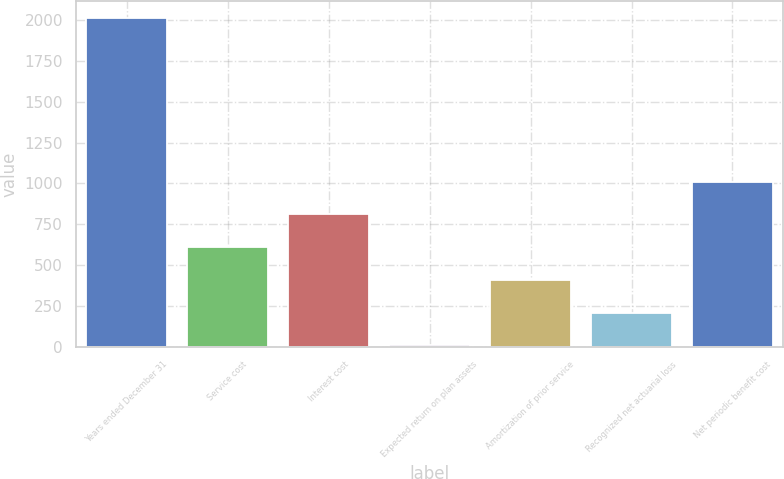<chart> <loc_0><loc_0><loc_500><loc_500><bar_chart><fcel>Years ended December 31<fcel>Service cost<fcel>Interest cost<fcel>Expected return on plan assets<fcel>Amortization of prior service<fcel>Recognized net actuarial loss<fcel>Net periodic benefit cost<nl><fcel>2016<fcel>610.4<fcel>811.2<fcel>8<fcel>409.6<fcel>208.8<fcel>1012<nl></chart> 